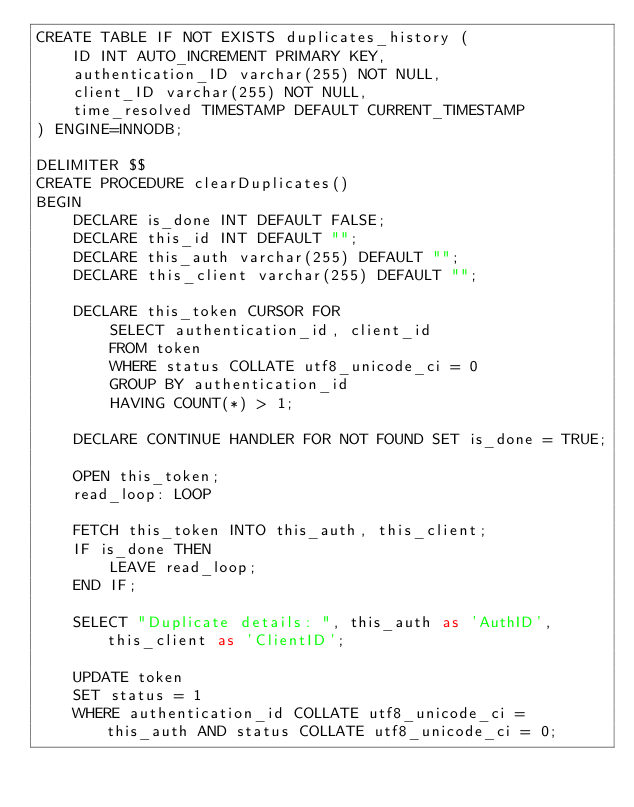Convert code to text. <code><loc_0><loc_0><loc_500><loc_500><_SQL_>CREATE TABLE IF NOT EXISTS duplicates_history (
    ID INT AUTO_INCREMENT PRIMARY KEY,
    authentication_ID varchar(255) NOT NULL,
    client_ID varchar(255) NOT NULL,
    time_resolved TIMESTAMP DEFAULT CURRENT_TIMESTAMP
) ENGINE=INNODB; 

DELIMITER $$
CREATE PROCEDURE clearDuplicates()
BEGIN 
    DECLARE is_done INT DEFAULT FALSE;
    DECLARE this_id INT DEFAULT "";
    DECLARE this_auth varchar(255) DEFAULT "";
    DECLARE this_client varchar(255) DEFAULT "";
    
    DECLARE this_token CURSOR FOR
        SELECT authentication_id, client_id
        FROM token
        WHERE status COLLATE utf8_unicode_ci = 0
        GROUP BY authentication_id
        HAVING COUNT(*) > 1;    
    
    DECLARE CONTINUE HANDLER FOR NOT FOUND SET is_done = TRUE;
    
    OPEN this_token;
    read_loop: LOOP
    
    FETCH this_token INTO this_auth, this_client; 
    IF is_done THEN
        LEAVE read_loop;  
    END IF;
    
    SELECT "Duplicate details: ", this_auth as 'AuthID', this_client as 'ClientID';    

    UPDATE token
    SET status = 1
    WHERE authentication_id COLLATE utf8_unicode_ci = this_auth AND status COLLATE utf8_unicode_ci = 0;
    </code> 